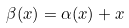<formula> <loc_0><loc_0><loc_500><loc_500>\beta ( x ) = \alpha ( x ) + x</formula> 